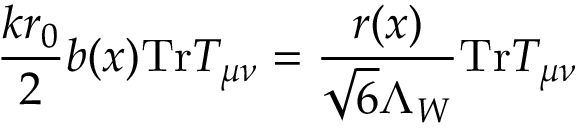Convert formula to latex. <formula><loc_0><loc_0><loc_500><loc_500>\frac { k r _ { 0 } } { 2 } b ( x ) T r T _ { \mu \nu } = \frac { r ( x ) } { \sqrt { 6 } \Lambda _ { W } } T r T _ { \mu \nu }</formula> 